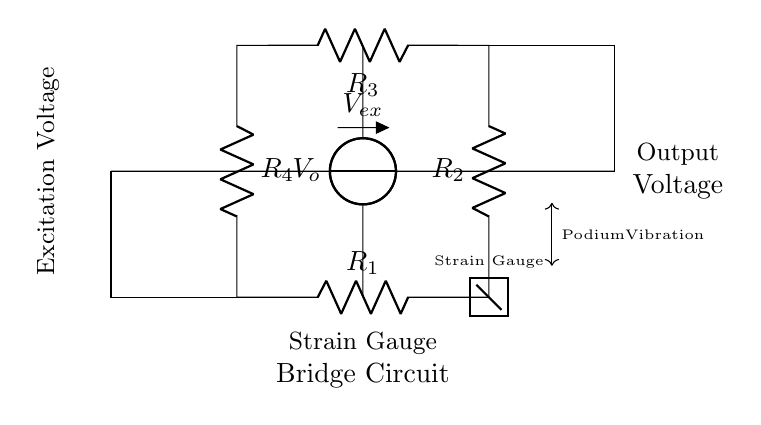What are the resistors in the strain gauge bridge circuit? The circuit includes four resistors labeled R1, R2, R3, and R4. These resistors are part of the Wheatstone bridge structure used for strain measurement.
Answer: R1, R2, R3, R4 What does the excitation voltage represent? The excitation voltage, denoted Vex, is the voltage supplied to the bridge circuit that enables the strain gauges to function. It also affects the output voltage measurements across the bridge.
Answer: Excitation voltage What is the purpose of the voltmeter in the diagram? The voltmeter, marked as Vo, is used to measure the output voltage across the bridge, which indicates the voltage change due to the strain experienced by the gauges when subjected to podium vibrations.
Answer: Output voltage How many strain gauges are indicated in the circuit? There is one strain gauge identified within the circuit, represented by a rectangle with a line through it, indicating its role in measuring the vibration effects.
Answer: One Why is the bridge configured with four resistors? The four resistors in a Wheatstone bridge configuration allow for precise measurement of resistance changes, which is necessary for accurately detecting small vibrations or strains in the podium during speeches.
Answer: Precision measurement What indicates podium vibration in this circuit? The diagram indicates podium vibration with a double-headed arrow pointing to a labeled space, which signifies the effect of any disturbances. This is crucial for understanding how vibrations are measured and interpreted in the context of public speaking.
Answer: Podium vibration 